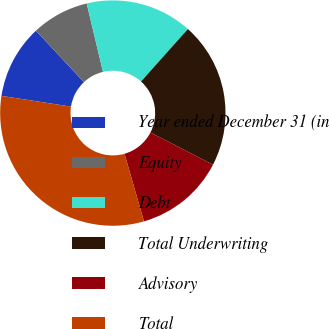<chart> <loc_0><loc_0><loc_500><loc_500><pie_chart><fcel>Year ended December 31 (in<fcel>Equity<fcel>Debt<fcel>Total Underwriting<fcel>Advisory<fcel>Total<nl><fcel>10.6%<fcel>8.23%<fcel>15.33%<fcel>20.97%<fcel>12.97%<fcel>31.89%<nl></chart> 